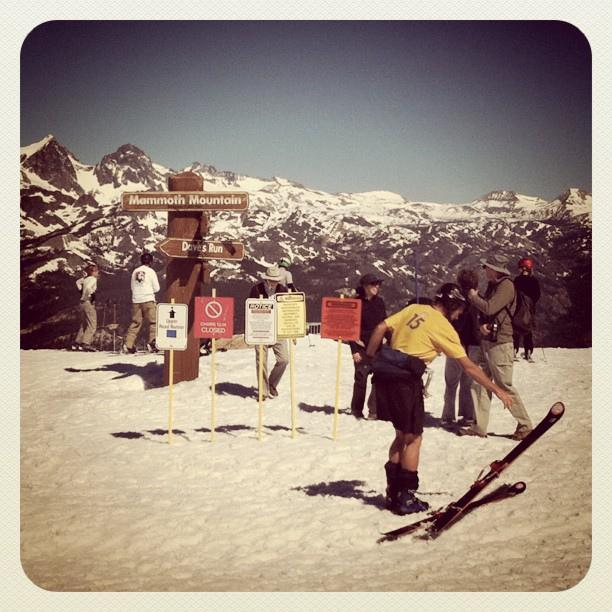Why is the man in the yellow shirt on the mountain? Please explain your reasoning. to ski. The man is is going to be skiing at some point. 